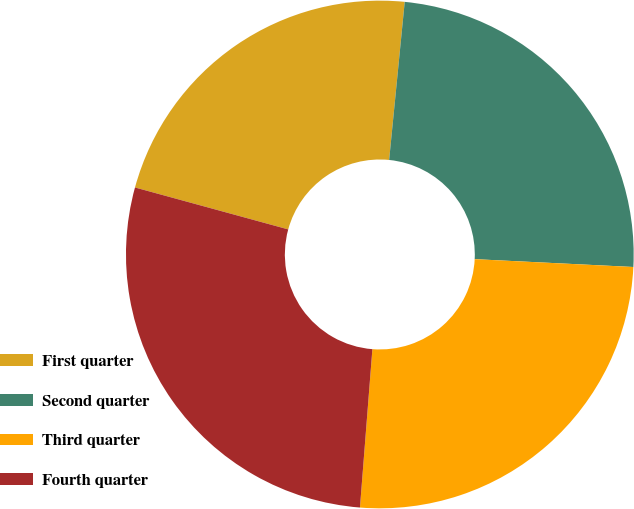Convert chart to OTSL. <chart><loc_0><loc_0><loc_500><loc_500><pie_chart><fcel>First quarter<fcel>Second quarter<fcel>Third quarter<fcel>Fourth quarter<nl><fcel>22.31%<fcel>24.22%<fcel>25.46%<fcel>28.0%<nl></chart> 